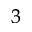Convert formula to latex. <formula><loc_0><loc_0><loc_500><loc_500>_ { 3 }</formula> 